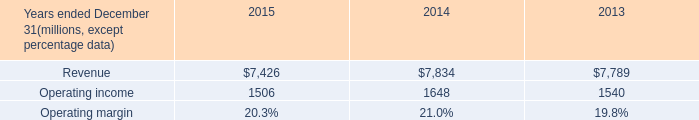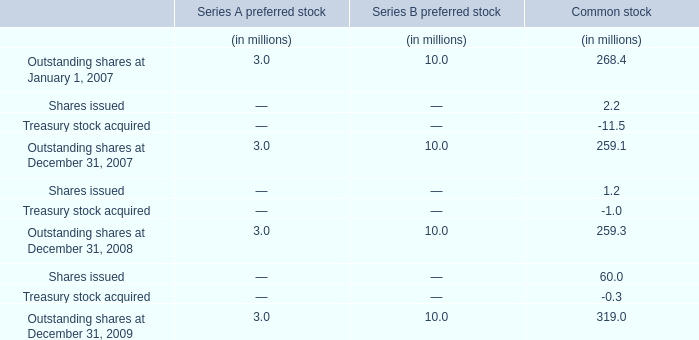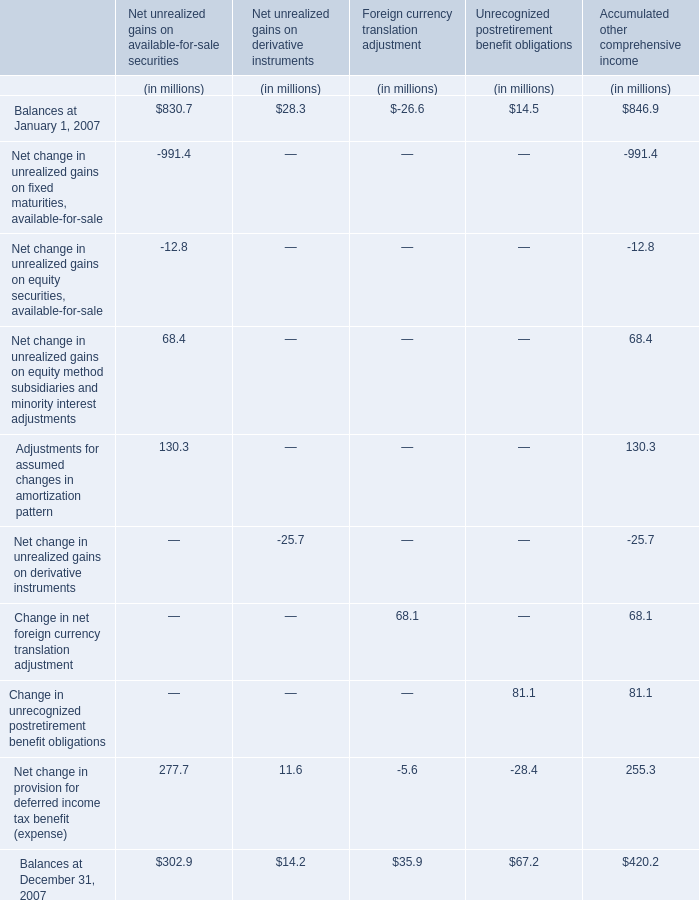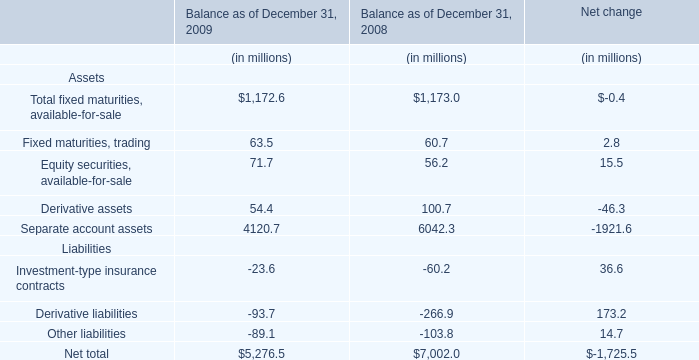Among 2007,2008 and 2009, which year is the Outstanding shares on December 31 for Common stock the most? 
Answer: 2009. 